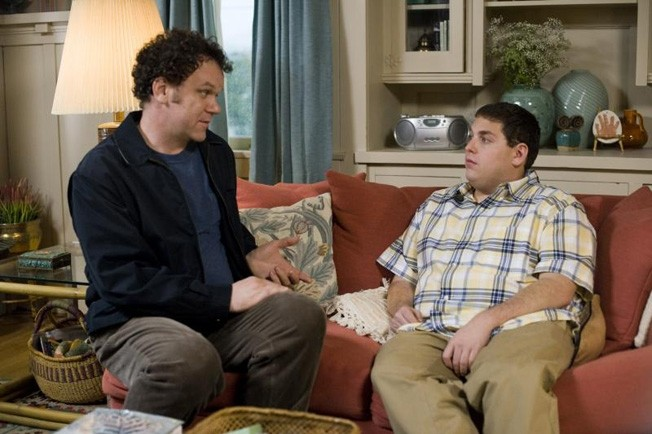Analyze the image in a comprehensive and detailed manner.
 In this image, actors John C Reilly and Jonah Hill are engrossed in a conversation in a scene from the movie "Cyrus". John C Reilly, dressed in a blue shirt and black jacket, is comfortably seated on a red couch. Jonah Hill, wearing a yellow and white striped shirt, is perched on the arm of the same couch. Their intense gaze at each other suggests a serious discussion. The setting is a cozy living room, adorned with a lamp, a bookshelf, and various decorations in the background. 